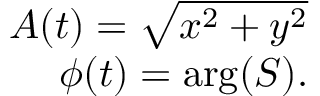<formula> <loc_0><loc_0><loc_500><loc_500>\begin{array} { r } { A ( t ) = \sqrt { x ^ { 2 } + y ^ { 2 } } } \\ { \phi ( t ) = \arg ( S ) . } \end{array}</formula> 